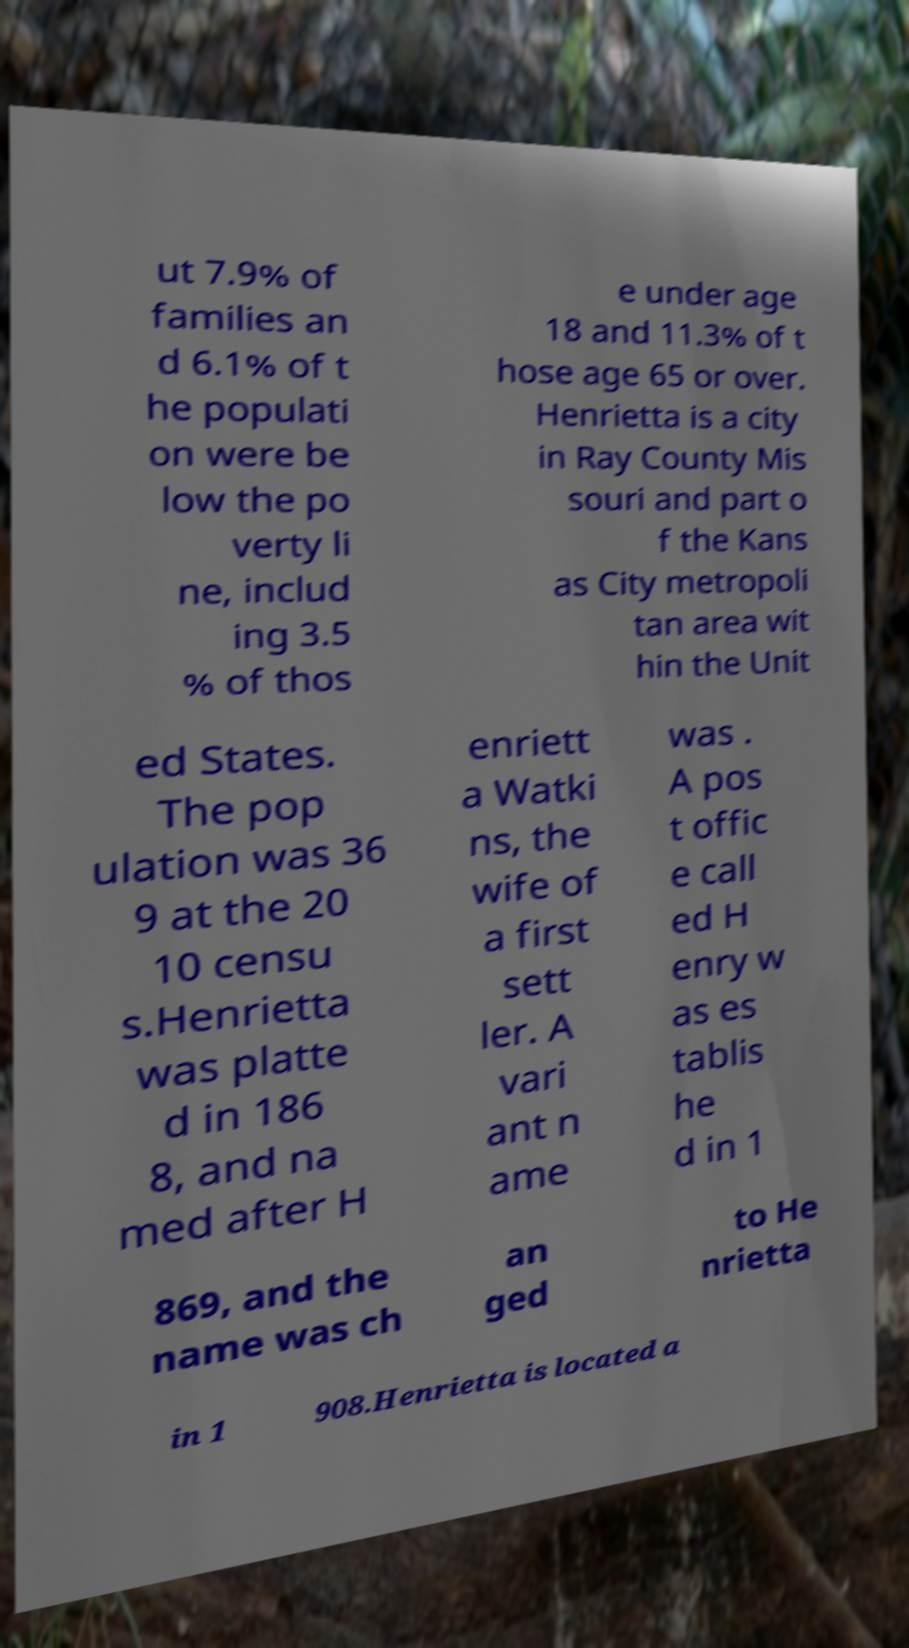Could you extract and type out the text from this image? ut 7.9% of families an d 6.1% of t he populati on were be low the po verty li ne, includ ing 3.5 % of thos e under age 18 and 11.3% of t hose age 65 or over. Henrietta is a city in Ray County Mis souri and part o f the Kans as City metropoli tan area wit hin the Unit ed States. The pop ulation was 36 9 at the 20 10 censu s.Henrietta was platte d in 186 8, and na med after H enriett a Watki ns, the wife of a first sett ler. A vari ant n ame was . A pos t offic e call ed H enry w as es tablis he d in 1 869, and the name was ch an ged to He nrietta in 1 908.Henrietta is located a 